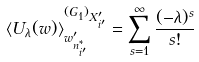Convert formula to latex. <formula><loc_0><loc_0><loc_500><loc_500>\langle U _ { \lambda } ( w ) \rangle _ { w _ { n _ { i ^ { \prime } } ^ { * } } ^ { \prime } } ^ { ( G _ { 1 } ) _ { X _ { i ^ { \prime } } ^ { \prime } } } = \sum _ { s = 1 } ^ { \infty } \frac { ( - \lambda ) ^ { s } } { s ! }</formula> 